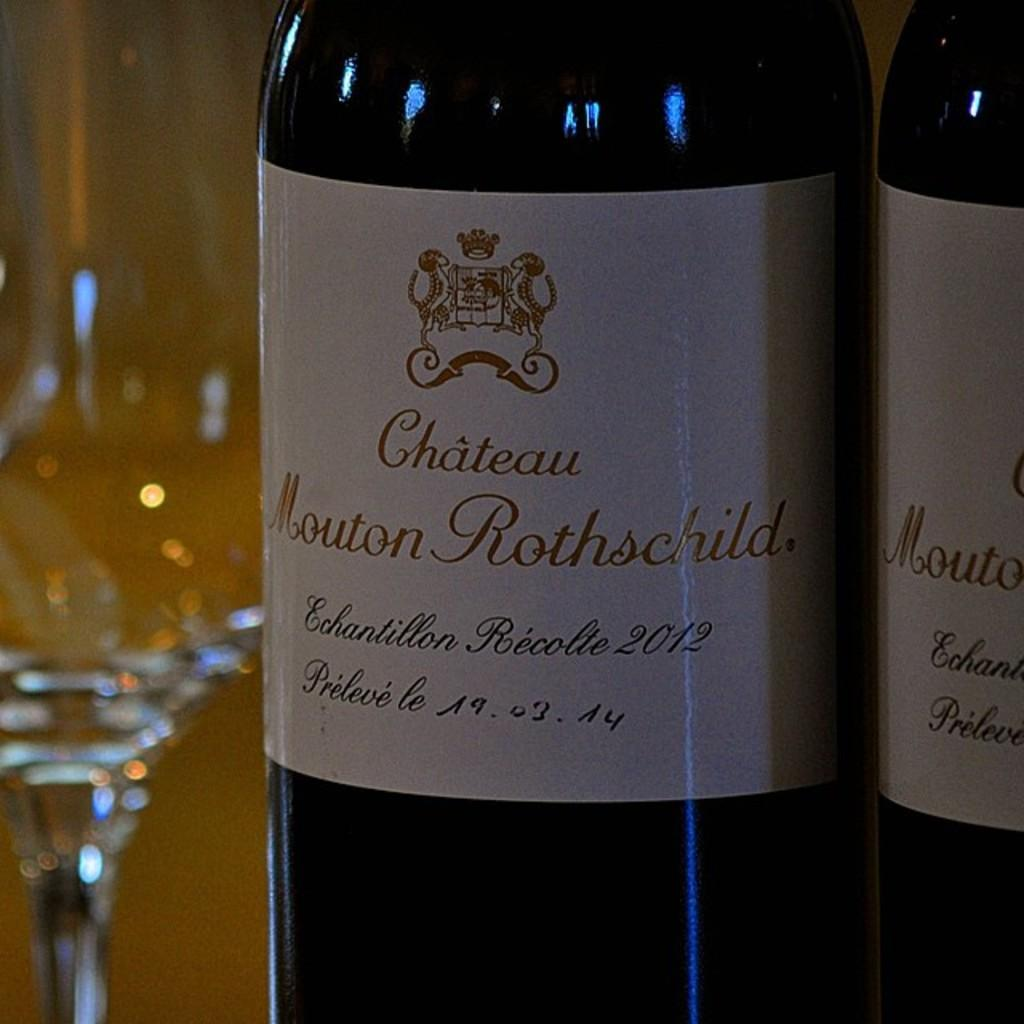Provide a one-sentence caption for the provided image. A bottle of Chateau Mouton Rothschild was bottled in 2012. 